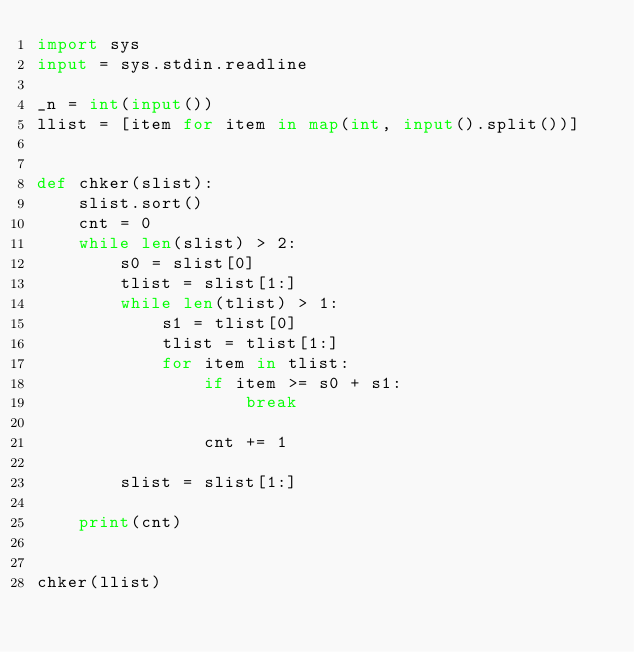Convert code to text. <code><loc_0><loc_0><loc_500><loc_500><_Python_>import sys
input = sys.stdin.readline

_n = int(input())
llist = [item for item in map(int, input().split())]


def chker(slist):
    slist.sort()
    cnt = 0
    while len(slist) > 2:
        s0 = slist[0]
        tlist = slist[1:]
        while len(tlist) > 1:
            s1 = tlist[0]
            tlist = tlist[1:]
            for item in tlist:
                if item >= s0 + s1:
                    break

                cnt += 1

        slist = slist[1:]

    print(cnt)


chker(llist)
</code> 